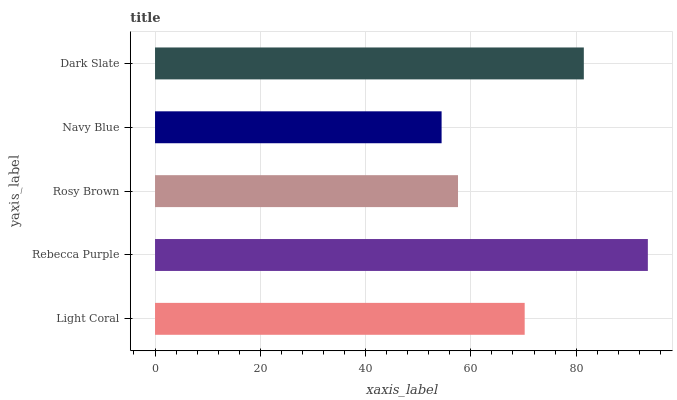Is Navy Blue the minimum?
Answer yes or no. Yes. Is Rebecca Purple the maximum?
Answer yes or no. Yes. Is Rosy Brown the minimum?
Answer yes or no. No. Is Rosy Brown the maximum?
Answer yes or no. No. Is Rebecca Purple greater than Rosy Brown?
Answer yes or no. Yes. Is Rosy Brown less than Rebecca Purple?
Answer yes or no. Yes. Is Rosy Brown greater than Rebecca Purple?
Answer yes or no. No. Is Rebecca Purple less than Rosy Brown?
Answer yes or no. No. Is Light Coral the high median?
Answer yes or no. Yes. Is Light Coral the low median?
Answer yes or no. Yes. Is Navy Blue the high median?
Answer yes or no. No. Is Rebecca Purple the low median?
Answer yes or no. No. 